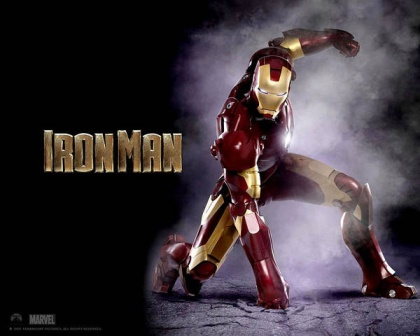Describe the following image. The image features the Marvel superhero Iron Man in an action-packed and dynamic pose. He is crouched down on one knee, with his left arm raised high and his right arm extended back, as if he's preparing to launch into the air or strike an enemy. Iron Man is adorned in his signature suit of armor, which prominently displays a rich red and vibrant gold color scheme. His suit looks sleek and powerful, with visible details in the design that emphasize its advanced technology. The background appears dark gray with a misty, purple haze that adds a dramatic effect to the scene. The name 'Iron Man' is written in bold, gold letters at the top left corner, adding to the overall impact of the image. 